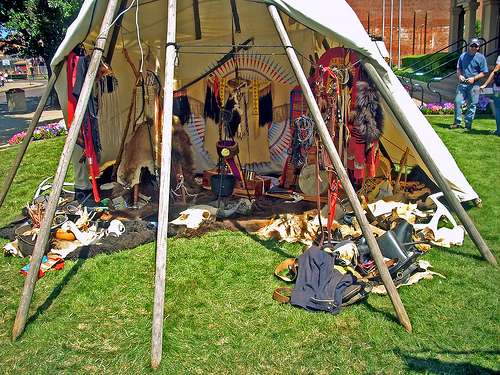<image>
Can you confirm if the dress is on the grass? Yes. Looking at the image, I can see the dress is positioned on top of the grass, with the grass providing support. Is there a grass on the man? No. The grass is not positioned on the man. They may be near each other, but the grass is not supported by or resting on top of the man. 